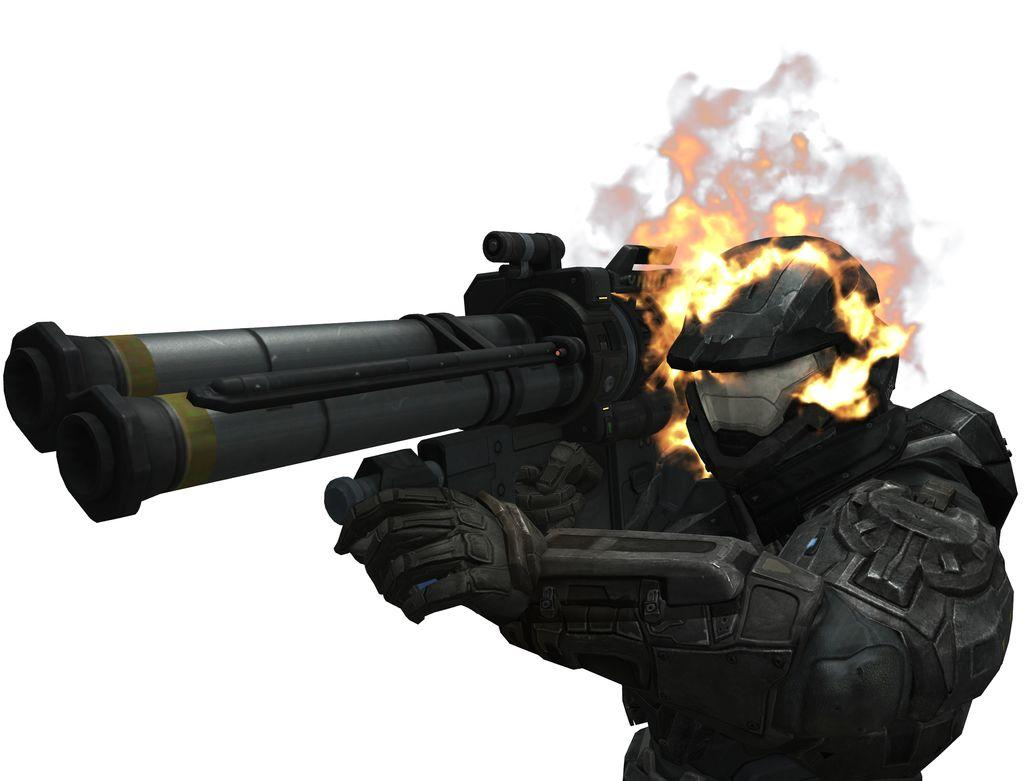What type of image is being described? The image is animated and edited. Can you describe any specific features or elements within the image? Unfortunately, the provided facts do not include any specific details about the content of the image. Where is the father sleeping in the image? There is no father or bed present in the image, as the provided facts only mention that it is animated and edited. 